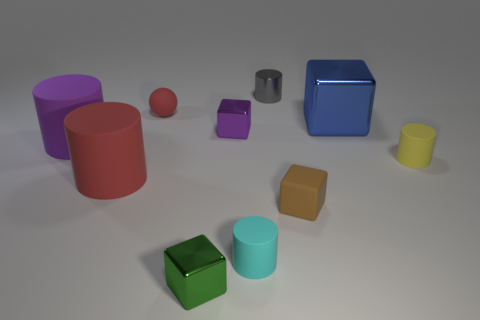There is a small shiny cube that is behind the brown thing; does it have the same color as the large rubber thing on the left side of the red rubber cylinder?
Provide a short and direct response. Yes. There is a red thing in front of the small rubber cylinder that is right of the small cylinder that is behind the blue object; what size is it?
Offer a terse response. Large. What shape is the large thing that is both behind the small yellow thing and on the left side of the green metal cube?
Provide a succinct answer. Cylinder. Are there the same number of shiny cubes behind the cyan rubber cylinder and small cubes that are left of the gray shiny cylinder?
Your answer should be compact. Yes. Is there a small thing that has the same material as the small gray cylinder?
Provide a short and direct response. Yes. Are the small cylinder on the right side of the matte block and the big red object made of the same material?
Make the answer very short. Yes. What size is the thing that is behind the purple cylinder and to the right of the brown thing?
Your answer should be compact. Large. The shiny cylinder has what color?
Your response must be concise. Gray. How many large purple cylinders are there?
Provide a short and direct response. 1. How many objects have the same color as the sphere?
Offer a very short reply. 1. 